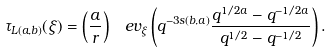Convert formula to latex. <formula><loc_0><loc_0><loc_500><loc_500>\tau _ { L ( a , b ) } ( \xi ) = \left ( \frac { a } { r } \right ) \, \ e v _ { \xi } \left ( q ^ { - 3 s ( b , a ) } \frac { q ^ { 1 / 2 a } - q ^ { - 1 / 2 a } } { q ^ { 1 / 2 } - q ^ { - 1 / 2 } } \right ) .</formula> 